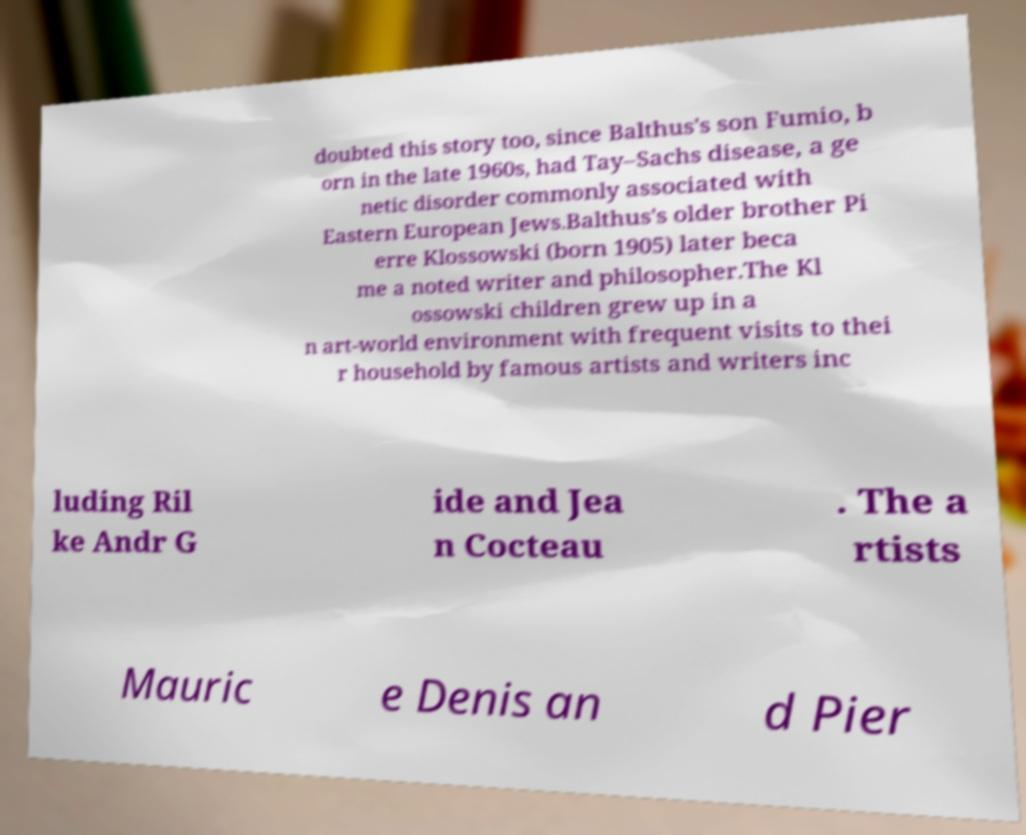I need the written content from this picture converted into text. Can you do that? doubted this story too, since Balthus's son Fumio, b orn in the late 1960s, had Tay–Sachs disease, a ge netic disorder commonly associated with Eastern European Jews.Balthus's older brother Pi erre Klossowski (born 1905) later beca me a noted writer and philosopher.The Kl ossowski children grew up in a n art-world environment with frequent visits to thei r household by famous artists and writers inc luding Ril ke Andr G ide and Jea n Cocteau . The a rtists Mauric e Denis an d Pier 